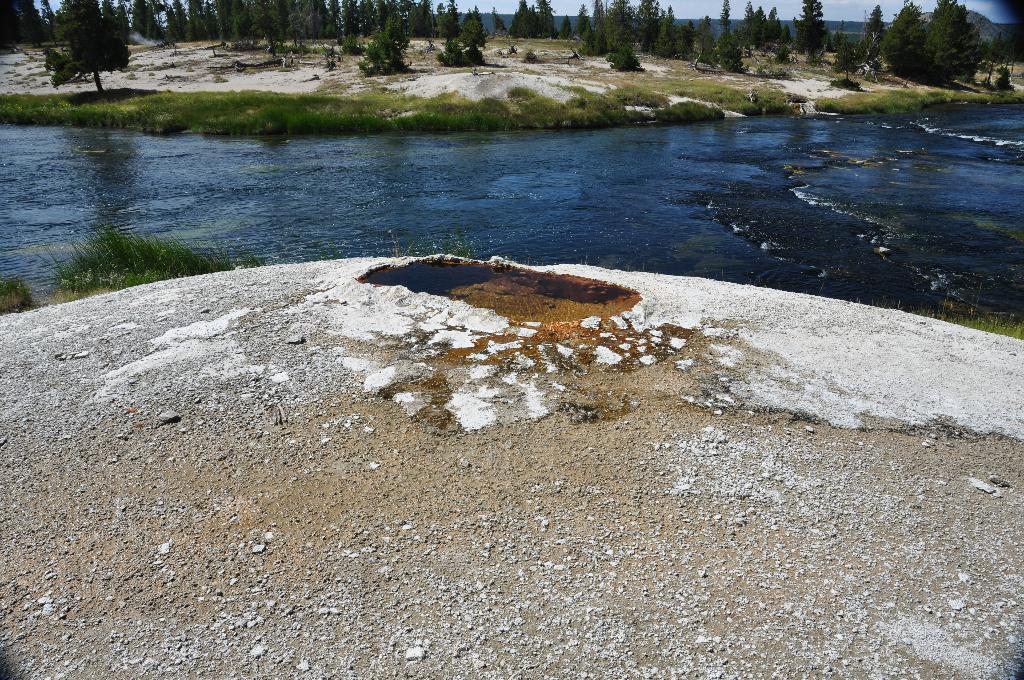In one or two sentences, can you explain what this image depicts? In this picture, we can see ground, water, grass, plants, trees, and the sky. 